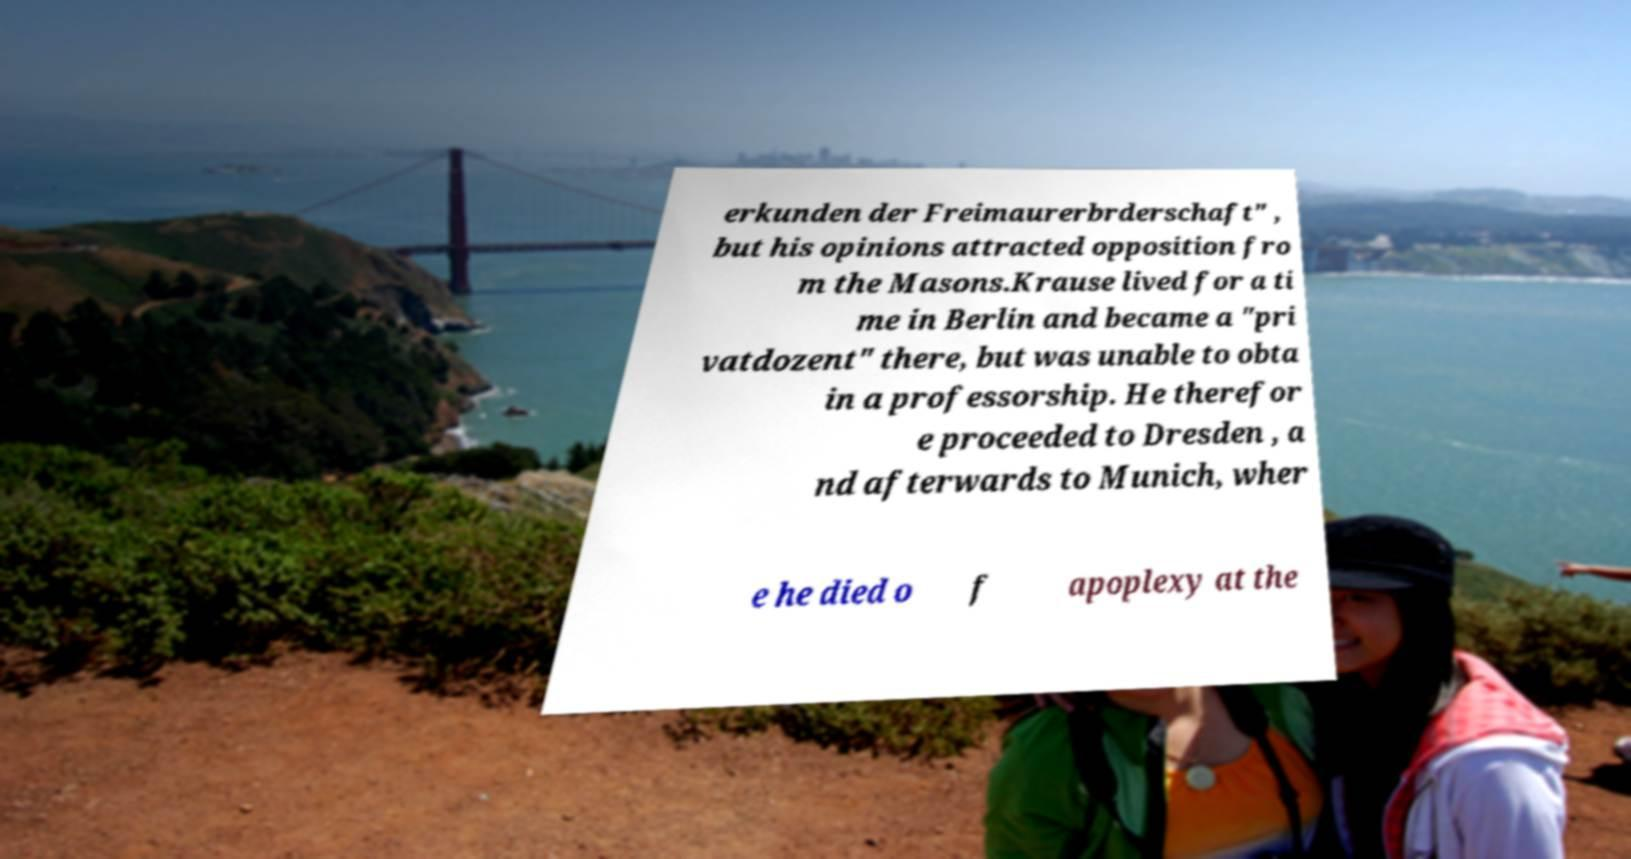Can you read and provide the text displayed in the image?This photo seems to have some interesting text. Can you extract and type it out for me? erkunden der Freimaurerbrderschaft" , but his opinions attracted opposition fro m the Masons.Krause lived for a ti me in Berlin and became a "pri vatdozent" there, but was unable to obta in a professorship. He therefor e proceeded to Dresden , a nd afterwards to Munich, wher e he died o f apoplexy at the 